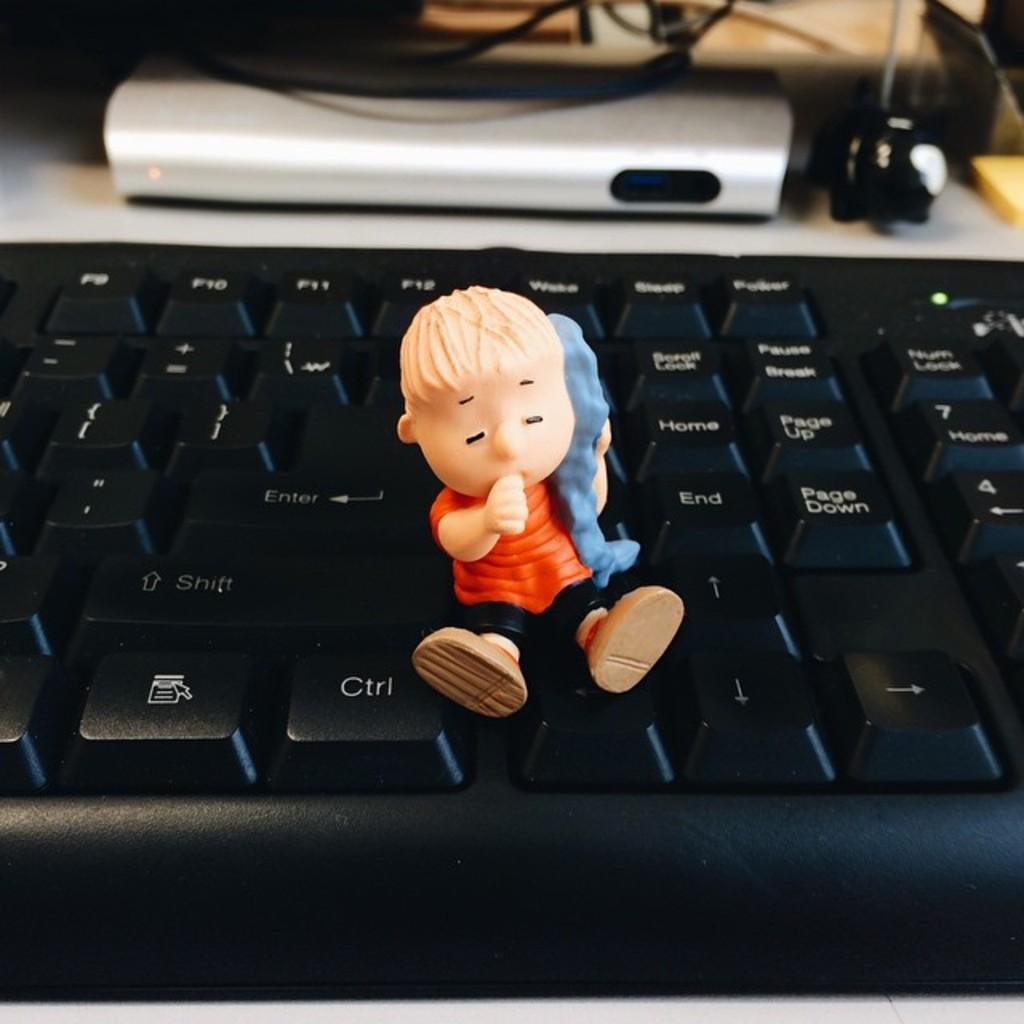What is on one of these keyboard keys?
Offer a very short reply. Ctrl. What button is the figures right foot touching?
Keep it short and to the point. Ctrl. 